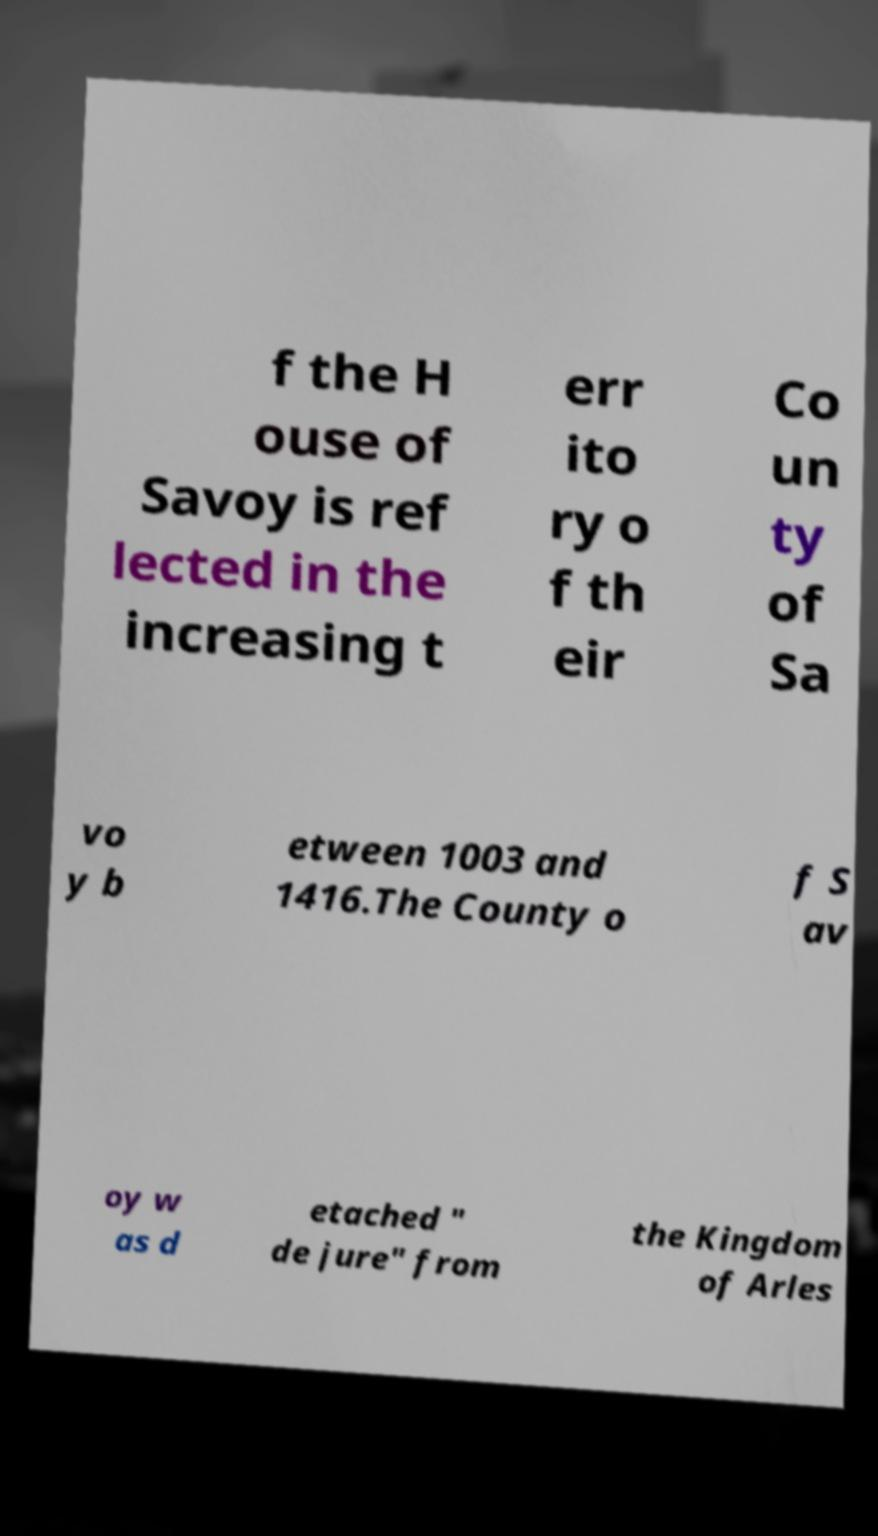Please read and relay the text visible in this image. What does it say? f the H ouse of Savoy is ref lected in the increasing t err ito ry o f th eir Co un ty of Sa vo y b etween 1003 and 1416.The County o f S av oy w as d etached " de jure" from the Kingdom of Arles 